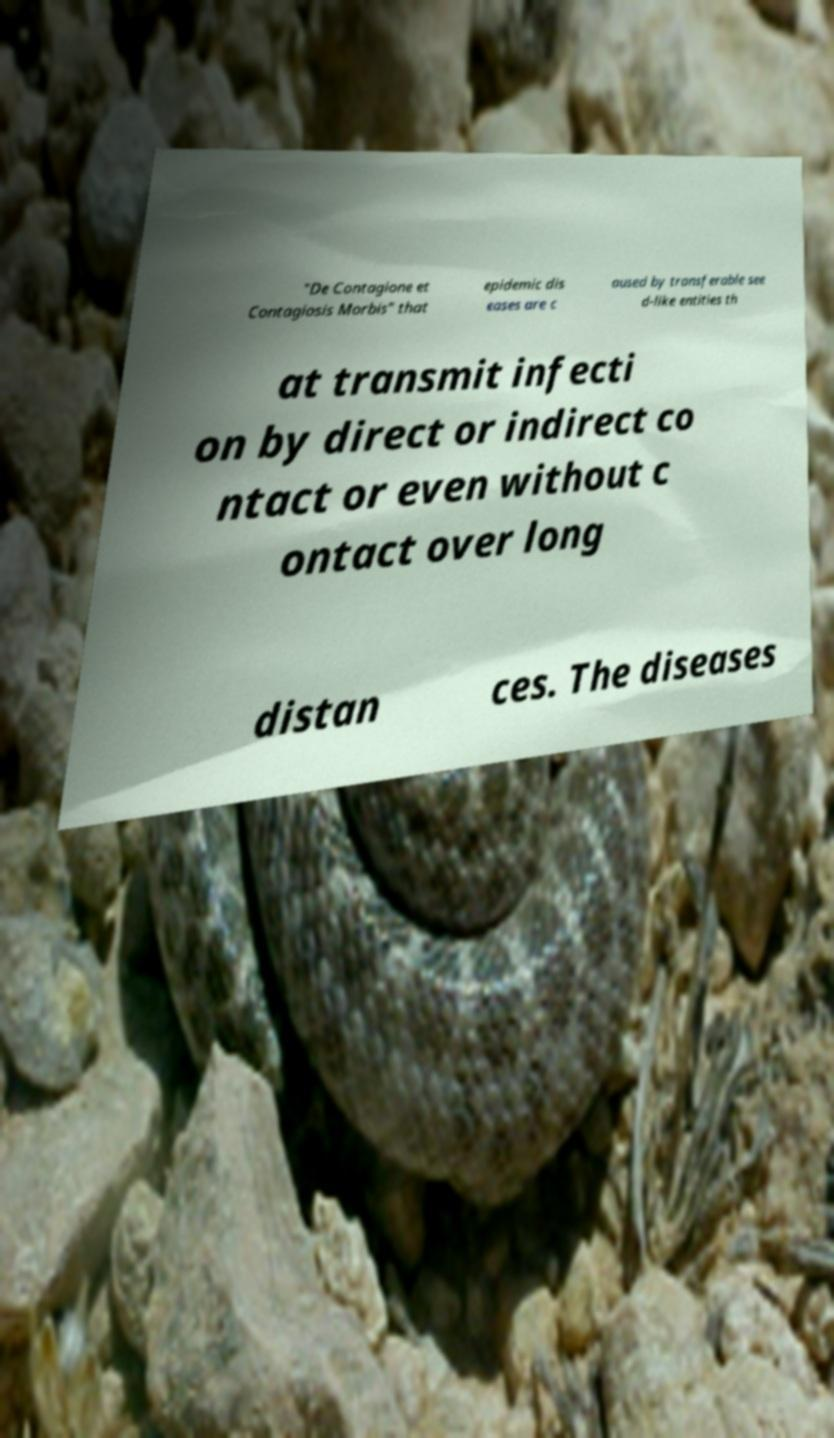Can you accurately transcribe the text from the provided image for me? "De Contagione et Contagiosis Morbis" that epidemic dis eases are c aused by transferable see d-like entities th at transmit infecti on by direct or indirect co ntact or even without c ontact over long distan ces. The diseases 